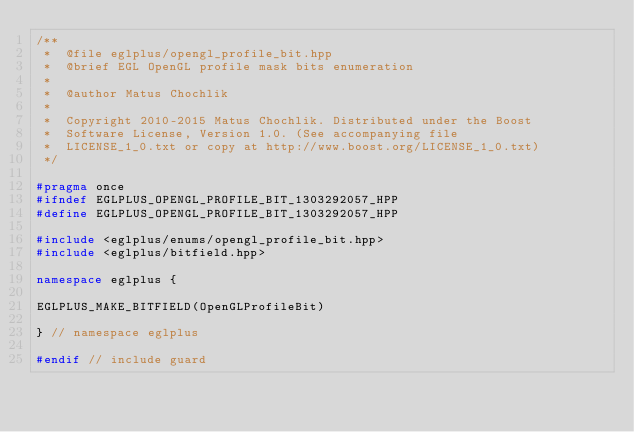<code> <loc_0><loc_0><loc_500><loc_500><_C++_>/**
 *  @file eglplus/opengl_profile_bit.hpp
 *  @brief EGL OpenGL profile mask bits enumeration
 *
 *  @author Matus Chochlik
 *
 *  Copyright 2010-2015 Matus Chochlik. Distributed under the Boost
 *  Software License, Version 1.0. (See accompanying file
 *  LICENSE_1_0.txt or copy at http://www.boost.org/LICENSE_1_0.txt)
 */

#pragma once
#ifndef EGLPLUS_OPENGL_PROFILE_BIT_1303292057_HPP
#define EGLPLUS_OPENGL_PROFILE_BIT_1303292057_HPP

#include <eglplus/enums/opengl_profile_bit.hpp>
#include <eglplus/bitfield.hpp>

namespace eglplus {

EGLPLUS_MAKE_BITFIELD(OpenGLProfileBit)

} // namespace eglplus

#endif // include guard
</code> 